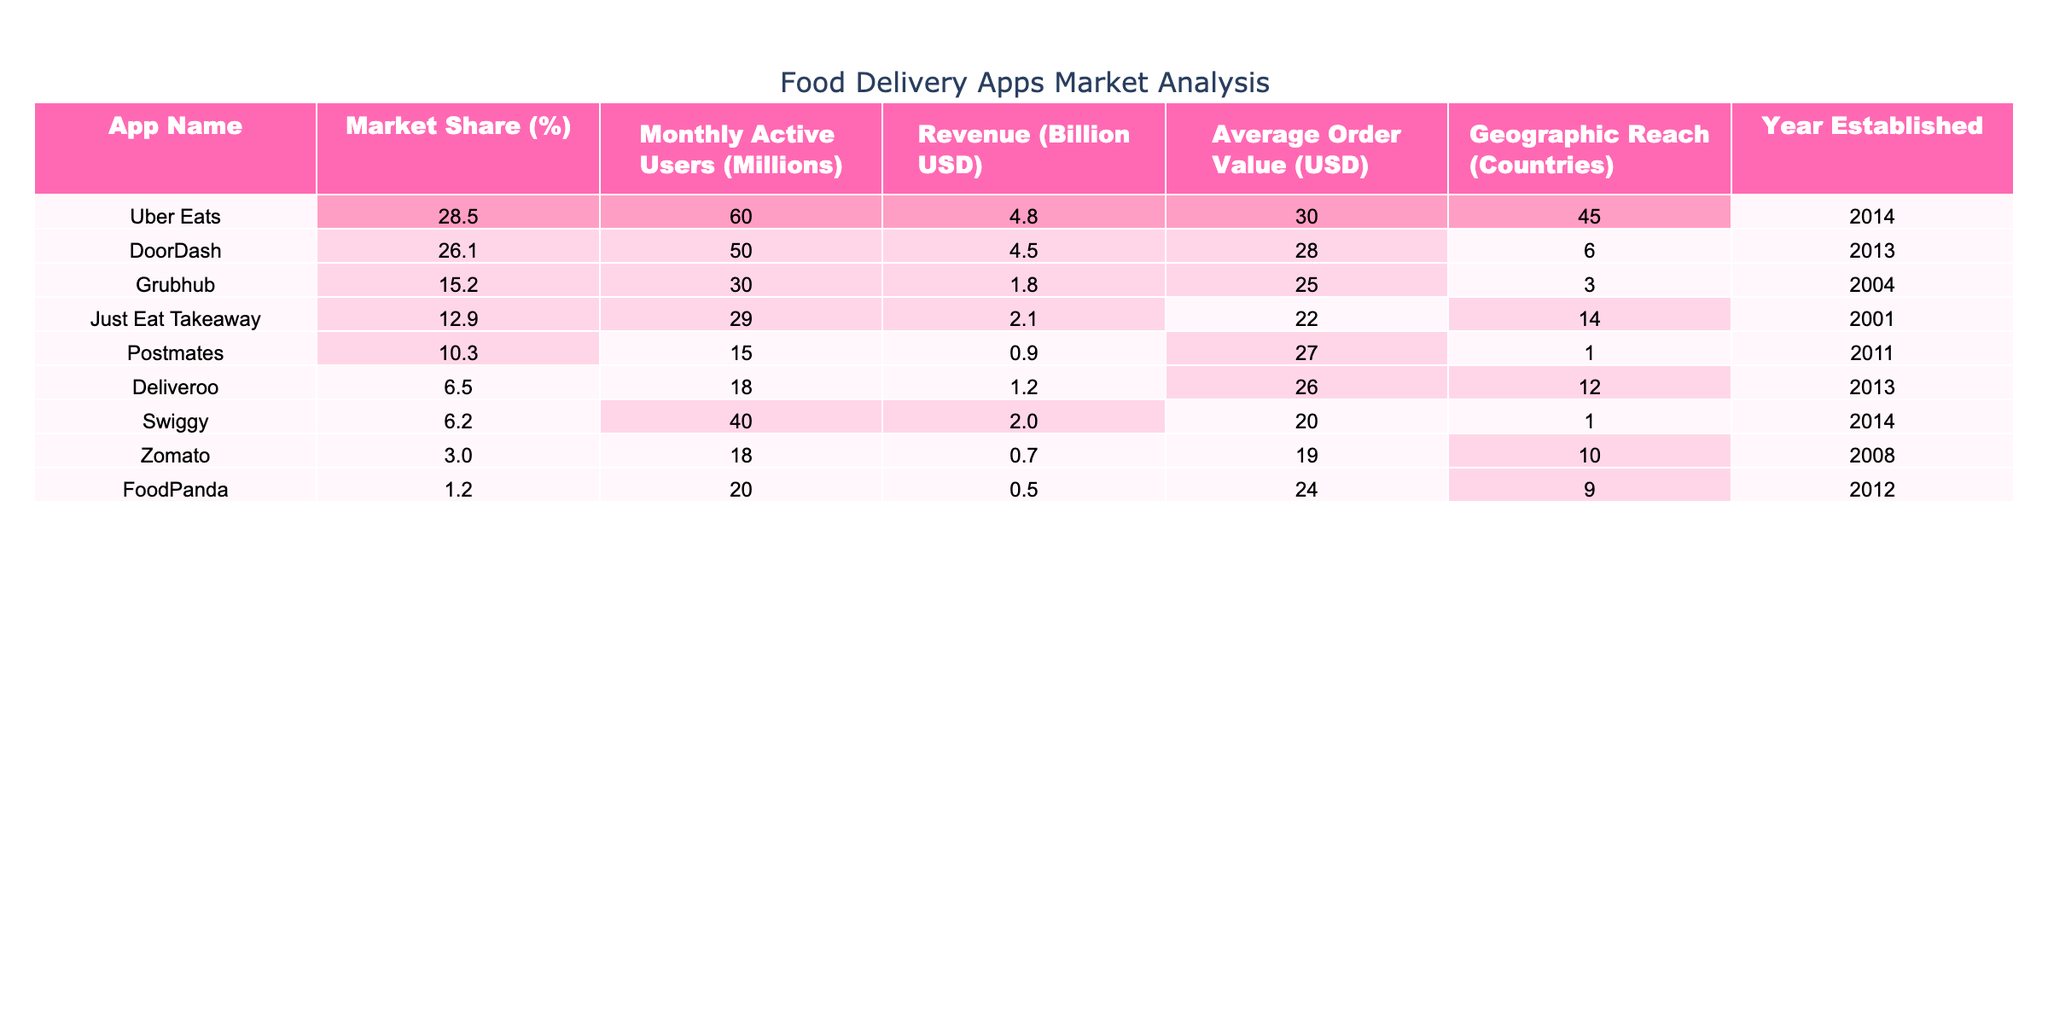What is the market share of Uber Eats? The table shows that Uber Eats has a market share of 28.5%.
Answer: 28.5% How many monthly active users does DoorDash have? According to the table, DoorDash has 50 million monthly active users.
Answer: 50 million What is the average order value of Grubhub? The average order value for Grubhub listed in the table is 25 USD.
Answer: 25 USD Which app has the highest revenue, and what is that amount? The table indicates that Uber Eats has the highest revenue at 4.8 billion USD.
Answer: 4.8 billion USD Is Postmates established after 2010? According to the table, Postmates was established in 2011, which is after 2010.
Answer: Yes What is the total revenue of both DoorDash and Grubhub combined? The revenue of DoorDash is 4.5 billion USD and Grubhub is 1.8 billion USD. Adding them gives 4.5 + 1.8 = 6.3 billion USD.
Answer: 6.3 billion USD Which app has the lowest geographic reach, and how many countries does it cover? The table shows that Postmates has the lowest geographic reach at 1 country.
Answer: Postmates, 1 country What is the average market share of all the apps listed? To find the average market share, sum the market shares: 28.5 + 26.1 + 15.2 + 12.9 + 10.3 + 6.5 + 6.2 + 3.0 + 1.2 = 109.9, then divide by the number of apps (9) to get 109.9 / 9 ≈ 12.21%.
Answer: 12.21% Which app was established first and in what year? The table indicates that Grubhub, established in 2004, is the oldest app listed.
Answer: Grubhub, 2004 Is the average order value of Deliveroo higher than that of Swiggy? Deliveroo’s average order value is 26 USD, while Swiggy’s is 20 USD. Thus, Deliveroo's average order value is higher.
Answer: Yes 